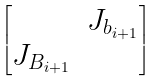Convert formula to latex. <formula><loc_0><loc_0><loc_500><loc_500>\begin{bmatrix} & J _ { b _ { i + 1 } } \\ J _ { B _ { i + 1 } } & \end{bmatrix}</formula> 